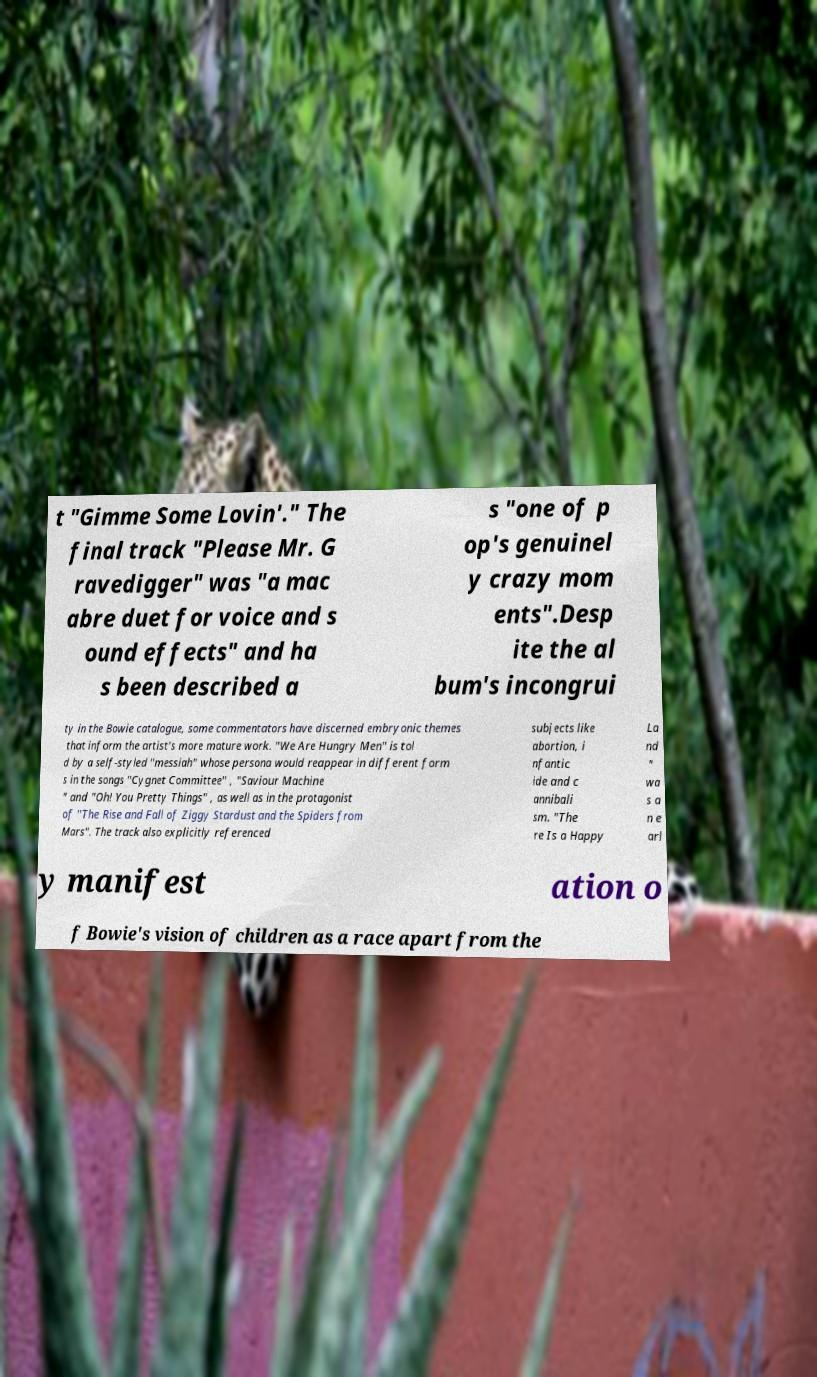Can you accurately transcribe the text from the provided image for me? t "Gimme Some Lovin'." The final track "Please Mr. G ravedigger" was "a mac abre duet for voice and s ound effects" and ha s been described a s "one of p op's genuinel y crazy mom ents".Desp ite the al bum's incongrui ty in the Bowie catalogue, some commentators have discerned embryonic themes that inform the artist's more mature work. "We Are Hungry Men" is tol d by a self-styled "messiah" whose persona would reappear in different form s in the songs "Cygnet Committee" , "Saviour Machine " and "Oh! You Pretty Things" , as well as in the protagonist of "The Rise and Fall of Ziggy Stardust and the Spiders from Mars". The track also explicitly referenced subjects like abortion, i nfantic ide and c annibali sm. "The re Is a Happy La nd " wa s a n e arl y manifest ation o f Bowie's vision of children as a race apart from the 